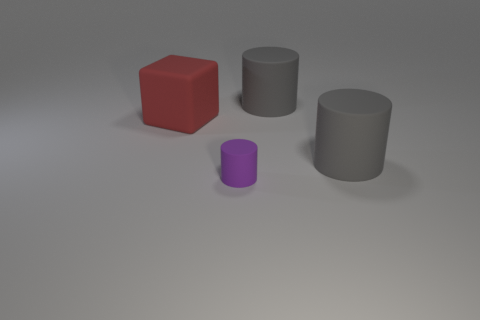What number of big gray things are in front of the large gray cylinder behind the matte thing to the left of the purple matte object?
Your answer should be very brief. 1. There is a big rubber object that is left of the small rubber thing; what color is it?
Provide a short and direct response. Red. There is a big rubber thing behind the large object on the left side of the small purple thing; what shape is it?
Give a very brief answer. Cylinder. How many cubes are tiny rubber objects or matte things?
Provide a succinct answer. 1. There is a cylinder that is in front of the red matte cube and on the right side of the tiny matte thing; what is its material?
Offer a very short reply. Rubber. How many big matte cubes are left of the small cylinder?
Offer a terse response. 1. Is the material of the object that is to the left of the tiny matte thing the same as the gray object that is in front of the red block?
Ensure brevity in your answer.  Yes. How many things are large cubes behind the purple cylinder or metal cylinders?
Your answer should be compact. 1. Are there fewer purple things left of the big red rubber thing than things that are left of the tiny cylinder?
Your response must be concise. Yes. What number of other things are the same size as the matte cube?
Provide a succinct answer. 2. 